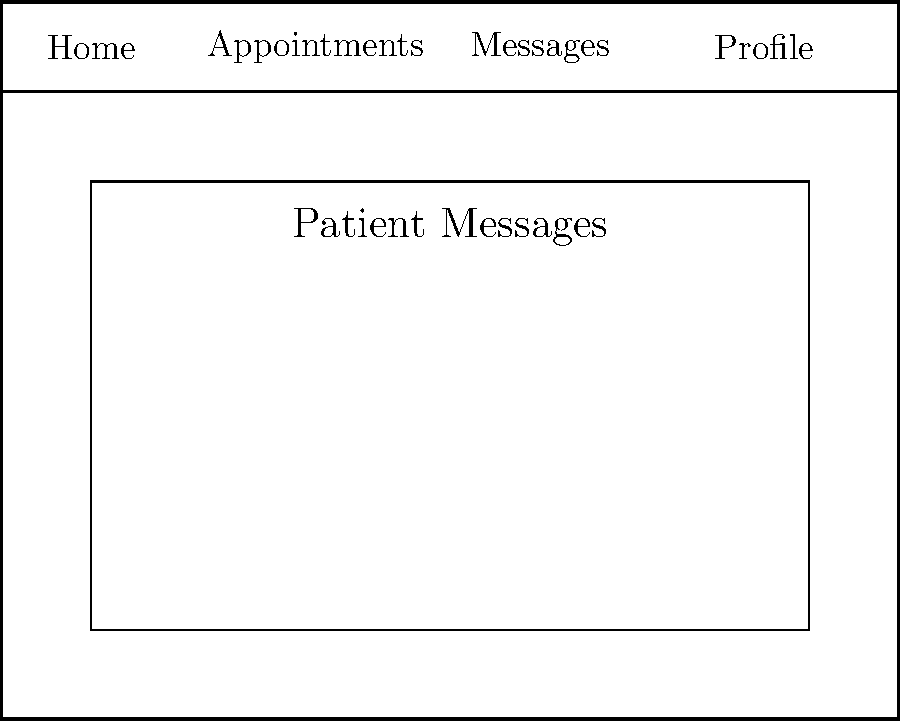In the simulated health portal interface shown above, which section would you click to initiate a new message to a patient? To initiate a new message to a patient in this simulated health portal interface, follow these steps:

1. Examine the interface layout:
   - The top bar contains navigation options: Home, Appointments, Messages, and Profile.
   - The main content area is labeled "Patient Messages" and displays a list of existing messages.

2. Look for options related to creating a new message:
   - The message list shows existing messages, but doesn't provide an option to create a new one.
   - At the bottom right of the content area, there's a button labeled "Compose".

3. Identify the purpose of the "Compose" button:
   - In messaging interfaces, "Compose" typically indicates the action to create a new message.
   - Its placement separate from the message list suggests it's a primary action for creating new content.

4. Conclude that the "Compose" button is the correct option:
   - Clicking this button would likely open a new message form or dialog to initiate a message to a patient.

Therefore, to initiate a new message to a patient, you would click on the "Compose" button located at the bottom right of the interface.
Answer: Compose button 